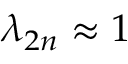<formula> <loc_0><loc_0><loc_500><loc_500>\lambda _ { 2 n } \approx 1</formula> 